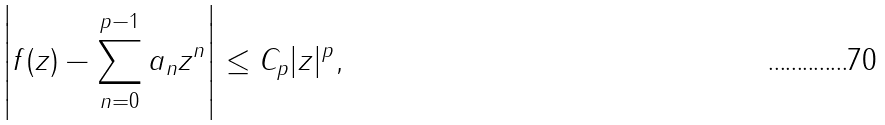<formula> <loc_0><loc_0><loc_500><loc_500>\left | f ( z ) - \sum _ { n = 0 } ^ { p - 1 } a _ { n } z ^ { n } \right | \leq C _ { p } | z | ^ { p } ,</formula> 